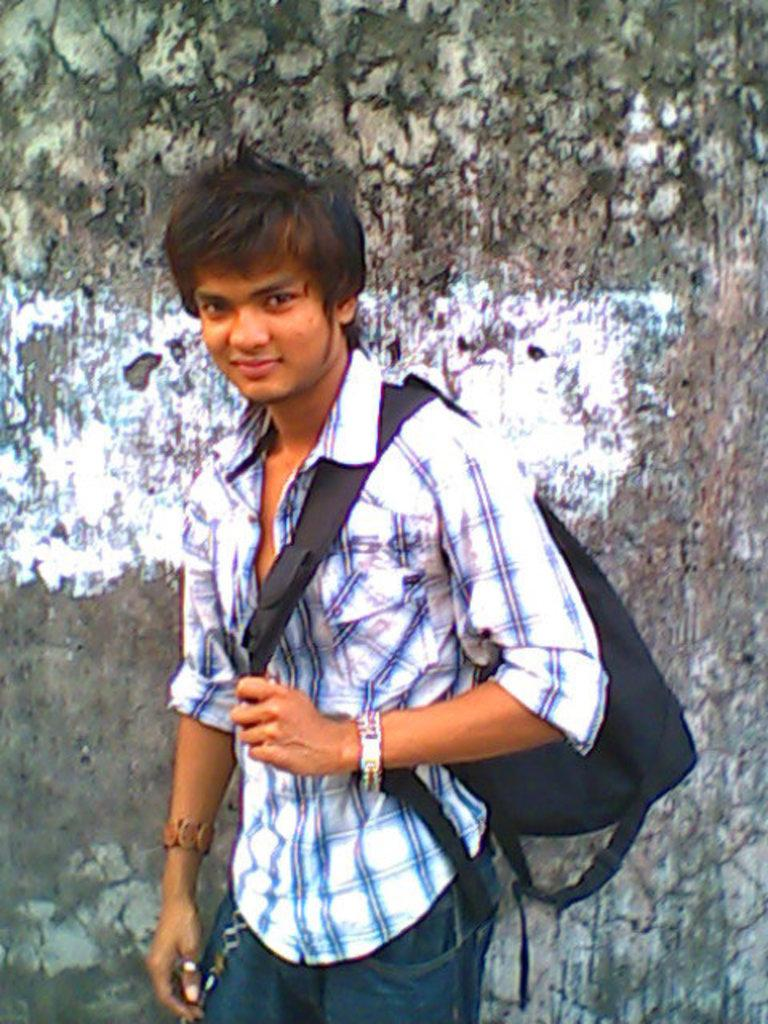What is the main subject of the image? There is a person standing in the image. What is the person holding on his back? The person is holding a black color bag on his back. What can be seen behind the person? There is a wall behind the person. Can you see any rabbits hopping around on the island in the image? There is no island or rabbits present in the image; it features a person standing with a black color bag on his back and a wall in the background. 